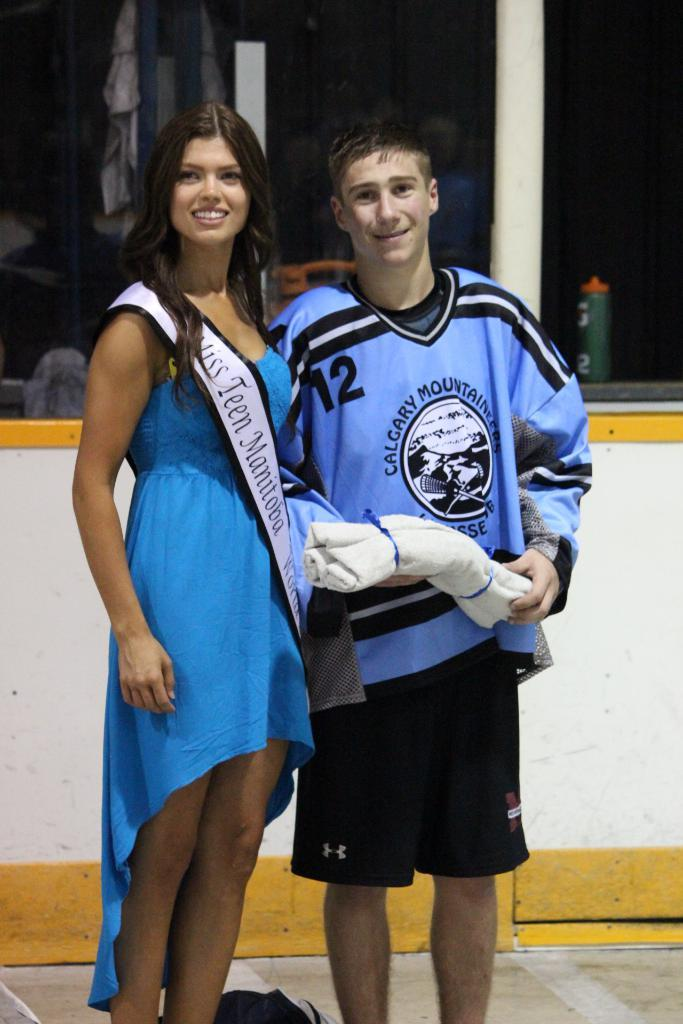<image>
Offer a succinct explanation of the picture presented. Player number 12 from the Calgary Mountaineers stands next to Miss Teen Manitoba. 